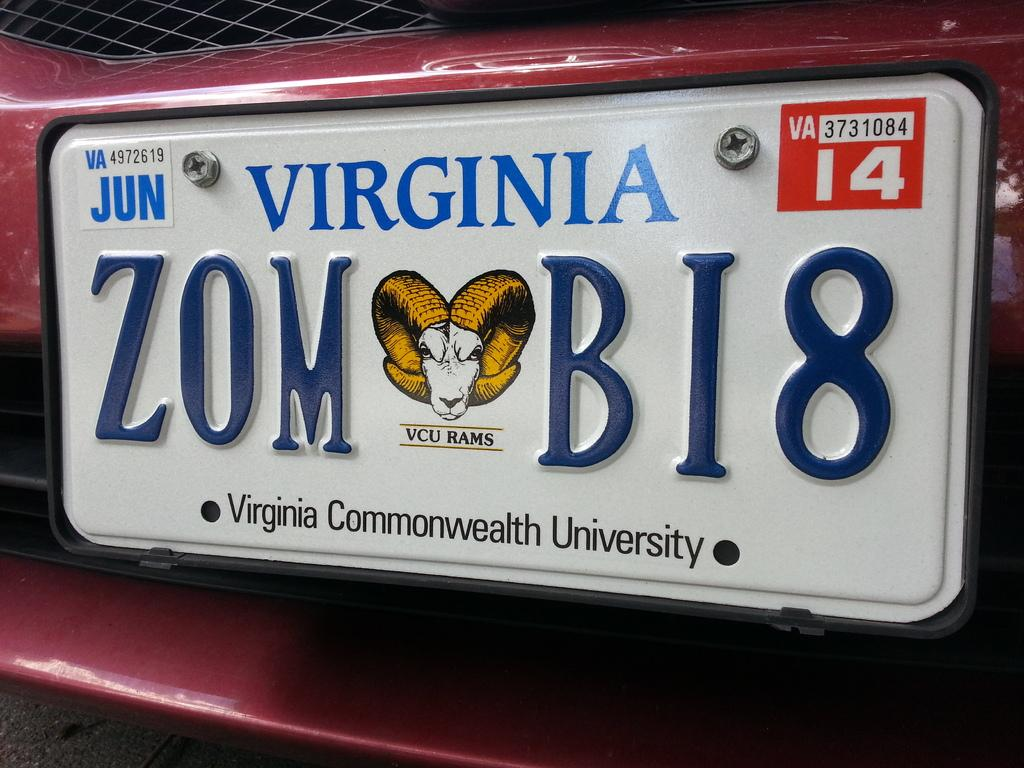<image>
Provide a brief description of the given image. a virginia license plate with the number 14 on it 